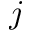<formula> <loc_0><loc_0><loc_500><loc_500>j</formula> 